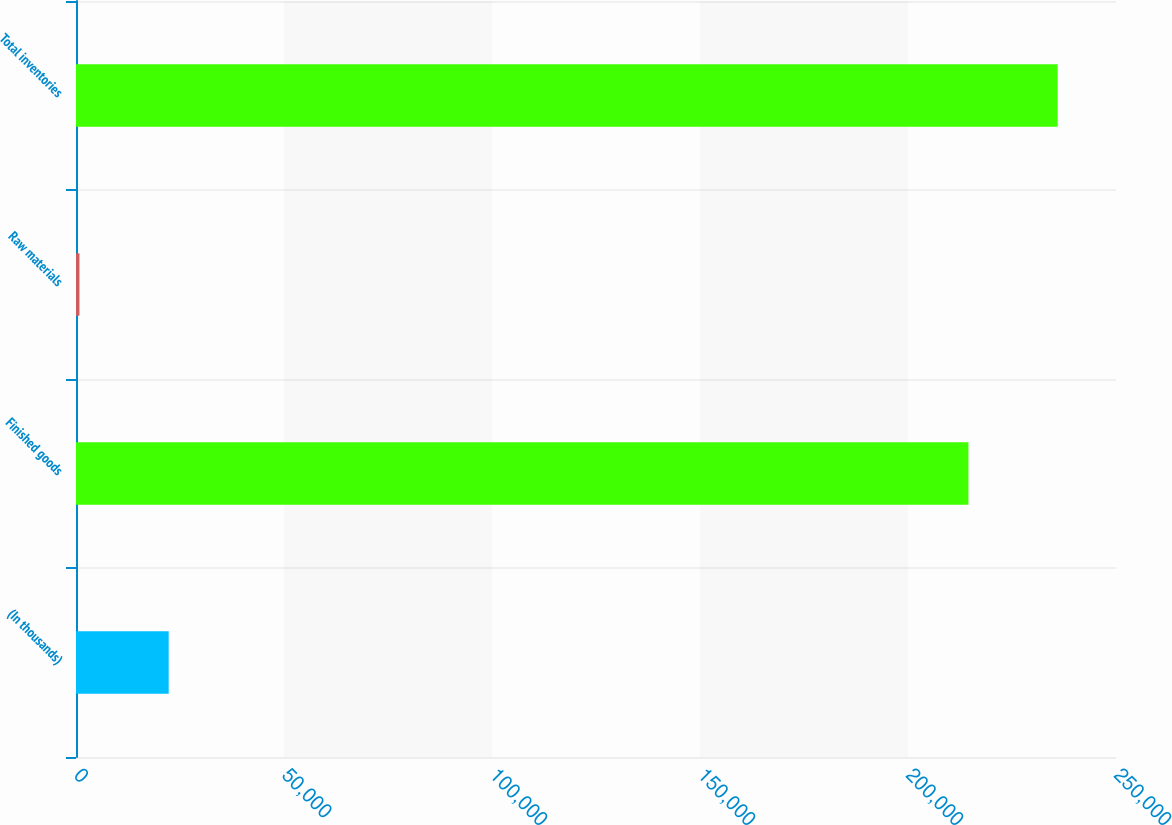<chart> <loc_0><loc_0><loc_500><loc_500><bar_chart><fcel>(In thousands)<fcel>Finished goods<fcel>Raw materials<fcel>Total inventories<nl><fcel>22283.4<fcel>214524<fcel>831<fcel>235976<nl></chart> 